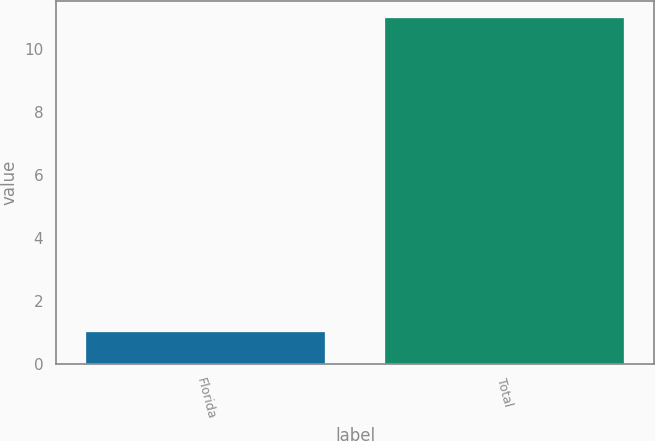Convert chart to OTSL. <chart><loc_0><loc_0><loc_500><loc_500><bar_chart><fcel>Florida<fcel>Total<nl><fcel>1<fcel>11<nl></chart> 